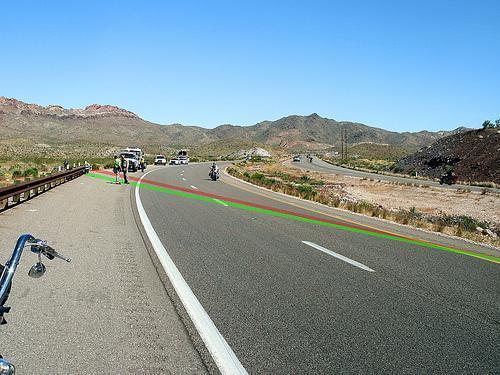How many policemen shown?
Give a very brief answer. 1. 